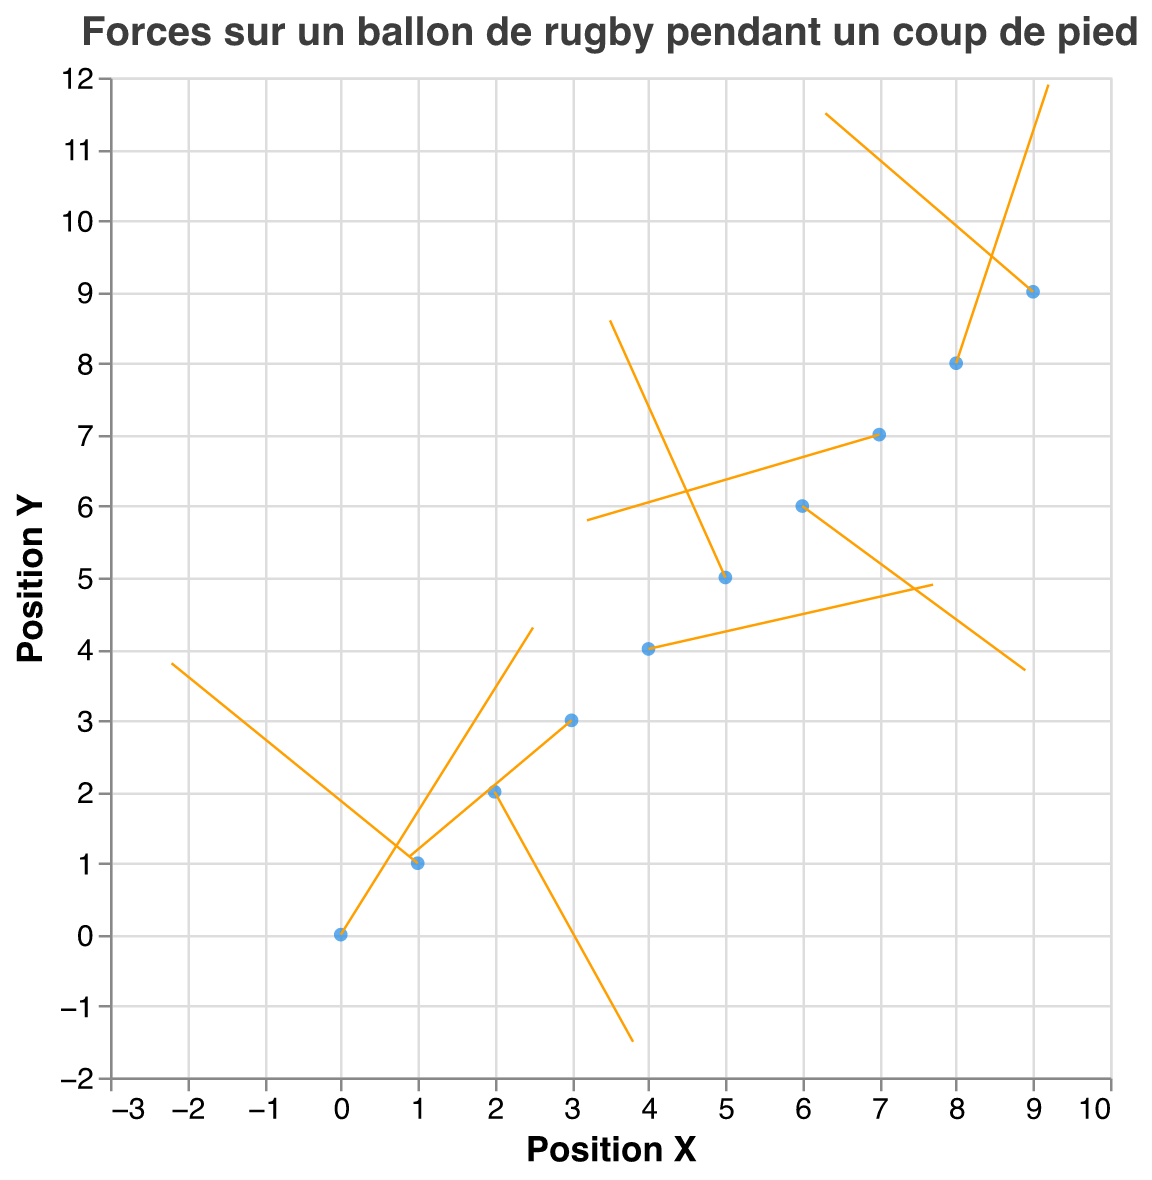How many data points are represented in the quiver plot? Count the number of points (X,Y) on the plot. Each point represents a data point.
Answer: 10 What is the title of the quiver plot? Read the title text located at the top of the plot.
Answer: "Forces sur un ballon de rugby pendant un coup de pied" What are the range values for the X and Y positions? Identify the minimum and maximum X and Y positions by observing the range of values on the plot.
Answer: X: 0-9, Y: 0-9 Which data point has the highest speed? Look for the vector with the highest "speed" value next to the data point in the plot.
Answer: (4, 4) with speed 35 What is the average angle of the forces? Sum all angle values and divide by the number of data points. Angles are 60, 45, 30, 75, 15, 90, 60, 45, 30, 75. Sum = 525. Average = 525/10 = 52.5
Answer: 52.5 Which data point shows the lowest magnitude of force? Identify the data point with the lowest "magnitude" value on the plot.
Answer: (3, 3) with magnitude 2.8 How many vectors indicate a downward force (negative v component)? Count the number of vectors with a negative v value. Negative v values are: (2,2), (3,3), (6,6), (7,7).
Answer: 4 Is there a data point where the force vector points directly horizontally? Check if there is any vector which has either u=0 (pure vertical) or v=0 (pure horizontal). Look for vectors with one component (u or v) as zero.
Answer: No What is the overall direction (visual observation) of the force vectors in the top-right quadrant? Observe the vectors located in the region with both X and Y coordinates greater than 4 and visually note their direction.
Answer: Vectors in the top-right quadrant mostly point to the right and upwards Which data point shows a force vector nearly perpendicular (90 degrees) to the X-axis? Look for vectors with an angle close to 90 degrees.
Answer: (5,5) with angle 90 